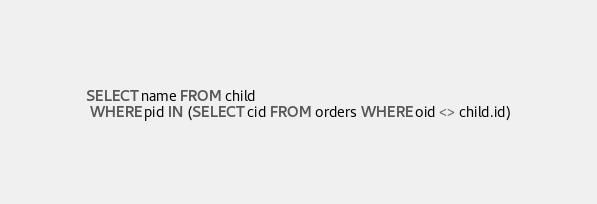<code> <loc_0><loc_0><loc_500><loc_500><_SQL_>SELECT name FROM child
 WHERE pid IN (SELECT cid FROM orders WHERE oid <> child.id)
</code> 